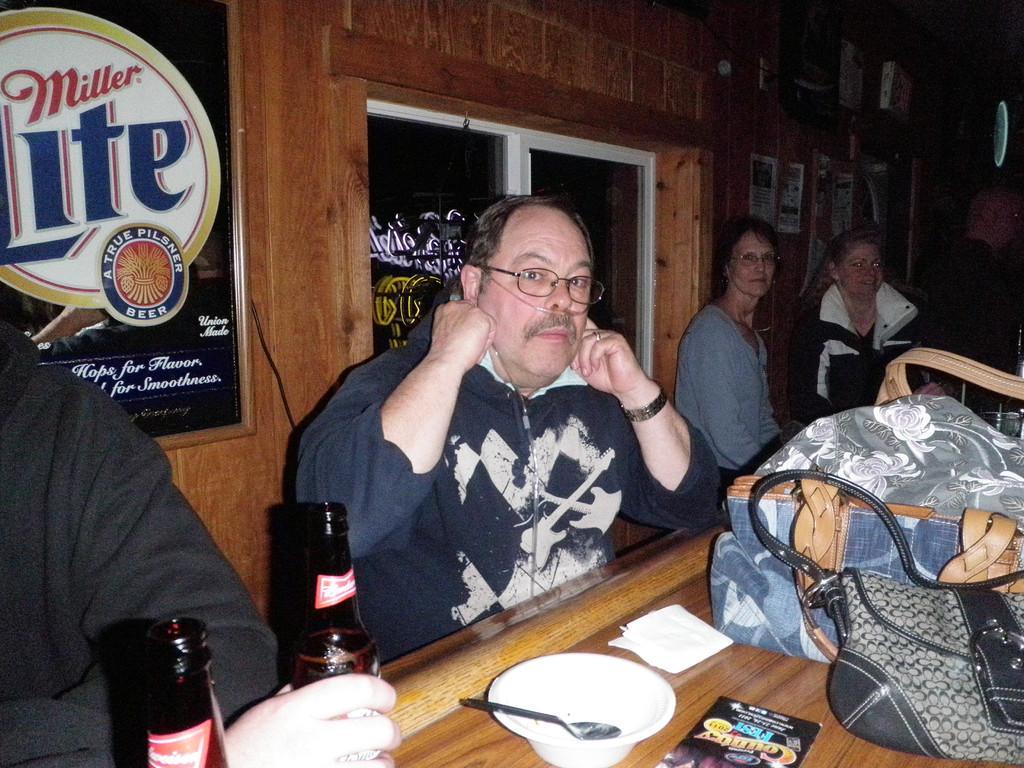Please provide a concise description of this image. There are few persons sitting on a bench and there is a table in front of them which has some objects on it. 